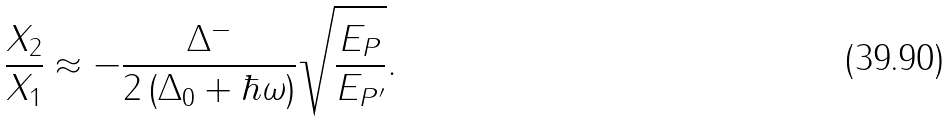<formula> <loc_0><loc_0><loc_500><loc_500>\frac { X _ { 2 } } { X _ { 1 } } \approx - \frac { \Delta ^ { - } } { 2 \left ( \Delta _ { 0 } + \hbar { \omega } \right ) } \sqrt { \frac { E _ { P } } { E _ { P ^ { \prime } } } } .</formula> 